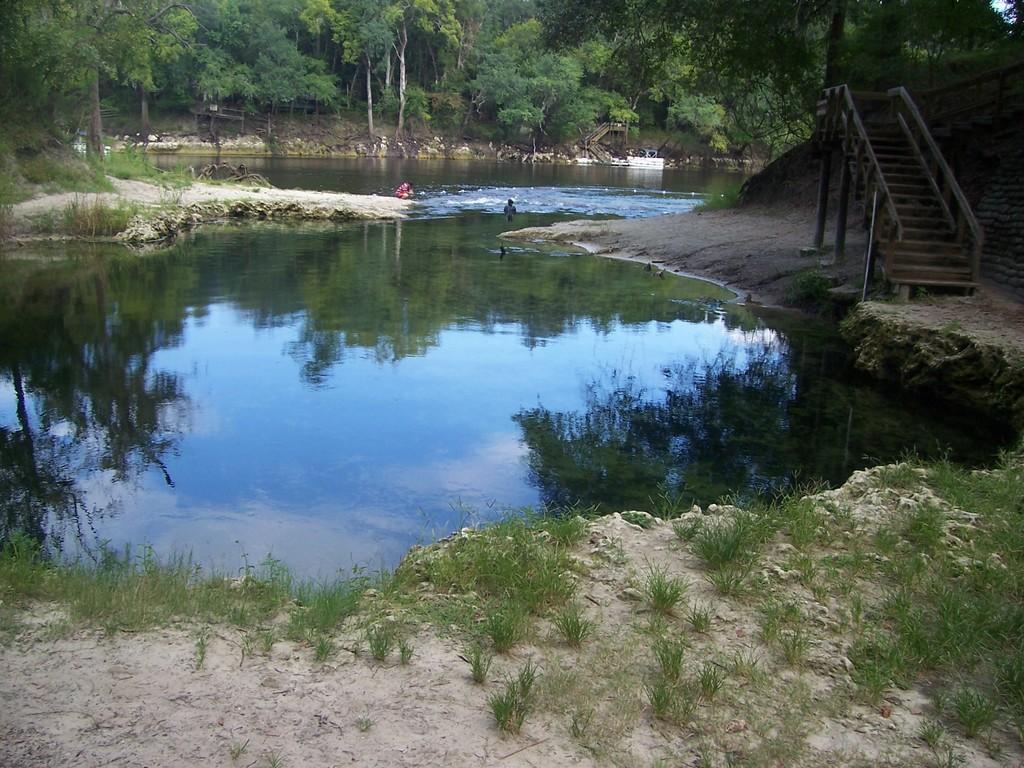How would you summarize this image in a sentence or two? In this image in front there is water. There are people. On the right side of the image there are stairs. In the background of the image there are trees. 